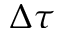<formula> <loc_0><loc_0><loc_500><loc_500>\Delta \tau</formula> 